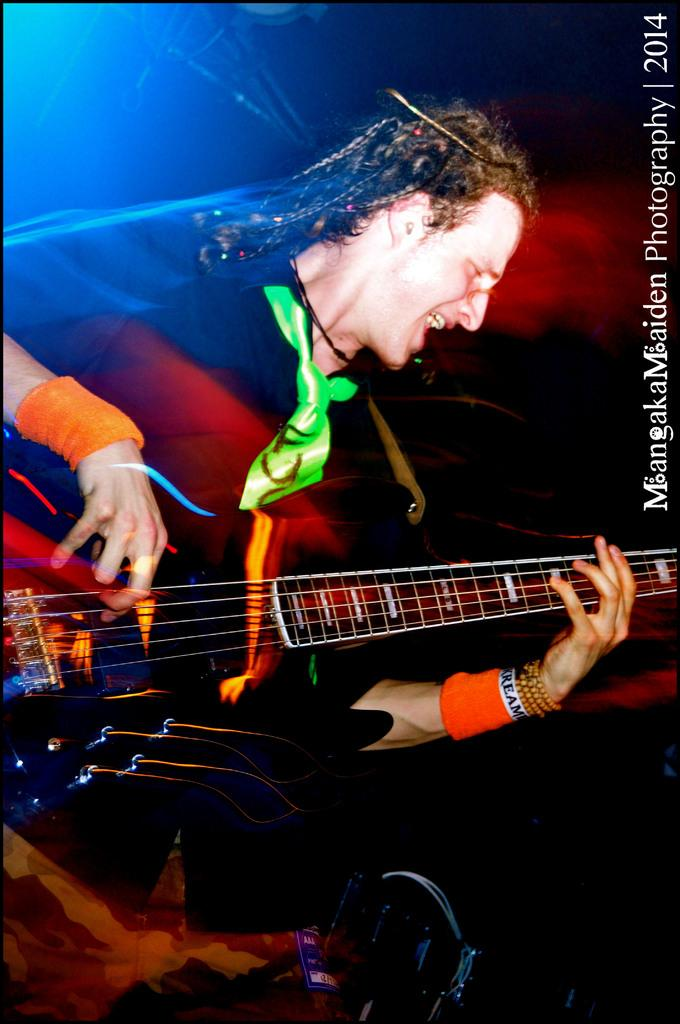What is the man in the image doing? The man is playing the guitar. How is the man playing the guitar? The man is using his hands to play the guitar. What type of disease is the man suffering from in the image? There is no indication of any disease in the image; the man is playing the guitar. How many chairs are visible in the image? There are no chairs visible in the image; the focus is on the man playing the guitar. 